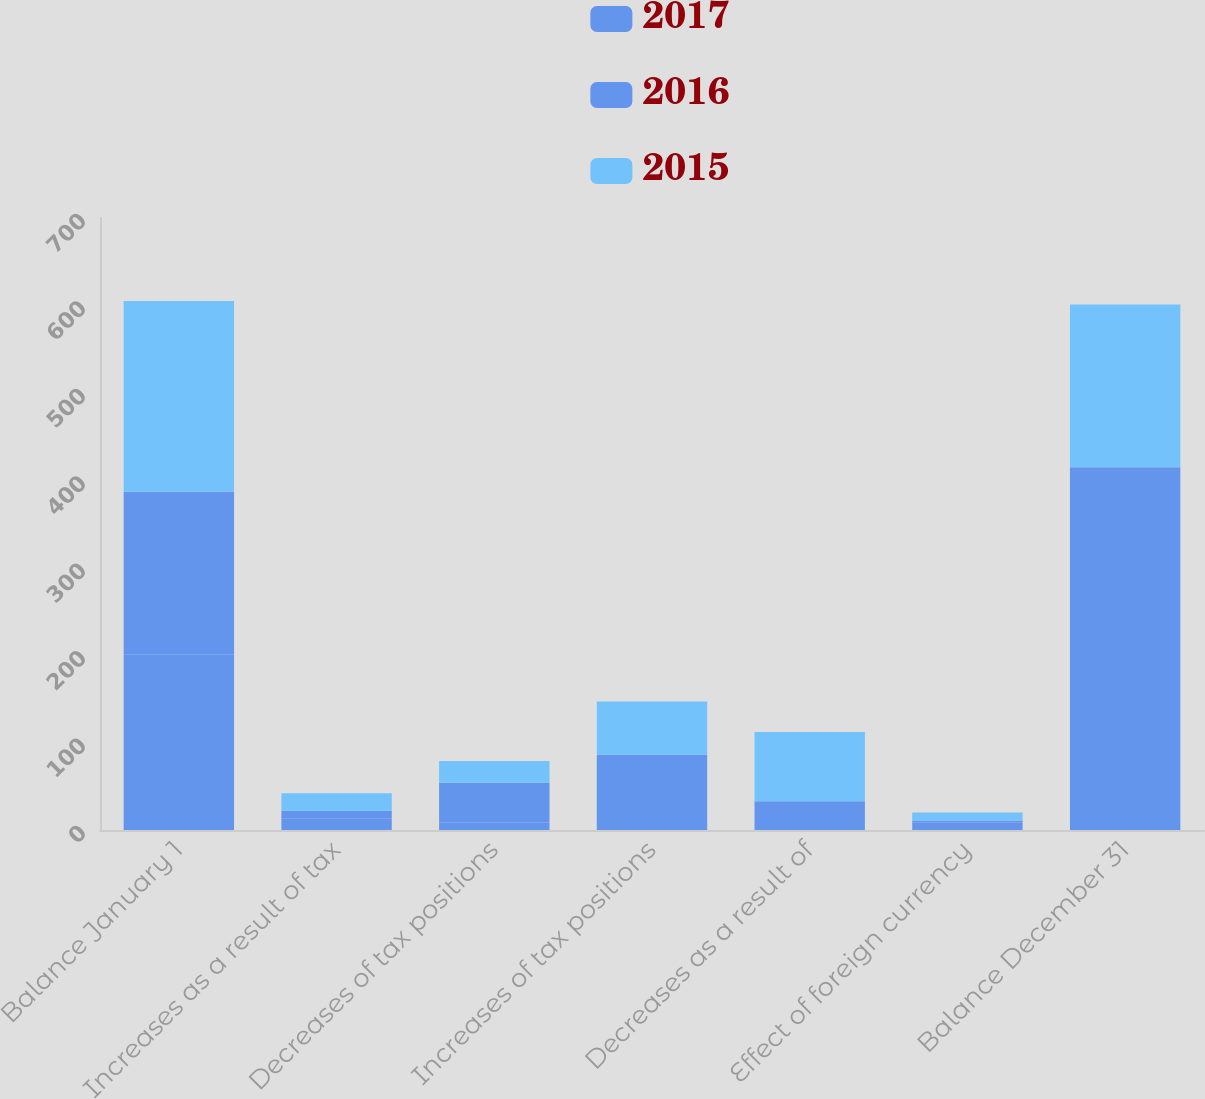Convert chart to OTSL. <chart><loc_0><loc_0><loc_500><loc_500><stacked_bar_chart><ecel><fcel>Balance January 1<fcel>Increases as a result of tax<fcel>Decreases of tax positions<fcel>Increases of tax positions<fcel>Decreases as a result of<fcel>Effect of foreign currency<fcel>Balance December 31<nl><fcel>2017<fcel>201<fcel>13<fcel>9<fcel>15<fcel>15<fcel>9<fcel>214<nl><fcel>2016<fcel>186<fcel>9<fcel>45<fcel>71<fcel>18<fcel>2<fcel>201<nl><fcel>2015<fcel>218<fcel>20<fcel>25<fcel>61<fcel>79<fcel>9<fcel>186<nl></chart> 